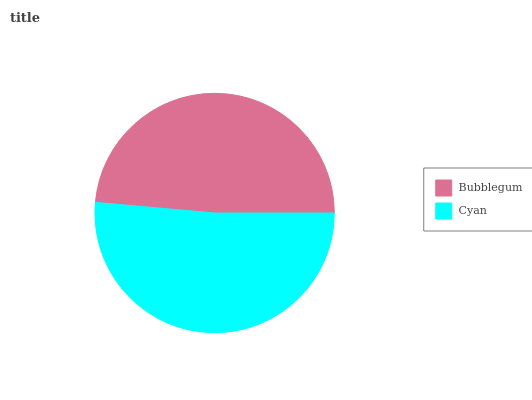Is Bubblegum the minimum?
Answer yes or no. Yes. Is Cyan the maximum?
Answer yes or no. Yes. Is Cyan the minimum?
Answer yes or no. No. Is Cyan greater than Bubblegum?
Answer yes or no. Yes. Is Bubblegum less than Cyan?
Answer yes or no. Yes. Is Bubblegum greater than Cyan?
Answer yes or no. No. Is Cyan less than Bubblegum?
Answer yes or no. No. Is Cyan the high median?
Answer yes or no. Yes. Is Bubblegum the low median?
Answer yes or no. Yes. Is Bubblegum the high median?
Answer yes or no. No. Is Cyan the low median?
Answer yes or no. No. 